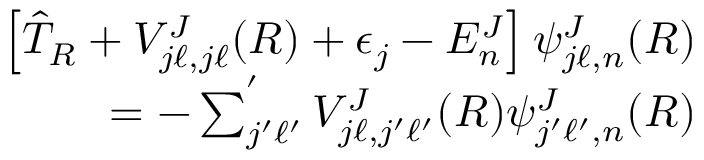<formula> <loc_0><loc_0><loc_500><loc_500>\begin{array} { r } { \left [ \hat { T } _ { R } + V _ { j \ell , j \ell } ^ { J } ( R ) + \epsilon _ { j } - E _ { n } ^ { J } \right ] \psi _ { j \ell , n } ^ { J } ( R ) } \\ { = - \sum _ { j ^ { \prime } \ell ^ { \prime } } ^ { ^ { \prime } } V _ { j \ell , j ^ { \prime } \ell ^ { \prime } } ^ { J } ( R ) \psi _ { j ^ { \prime } \ell ^ { \prime } , n } ^ { J } ( R ) } \end{array}</formula> 